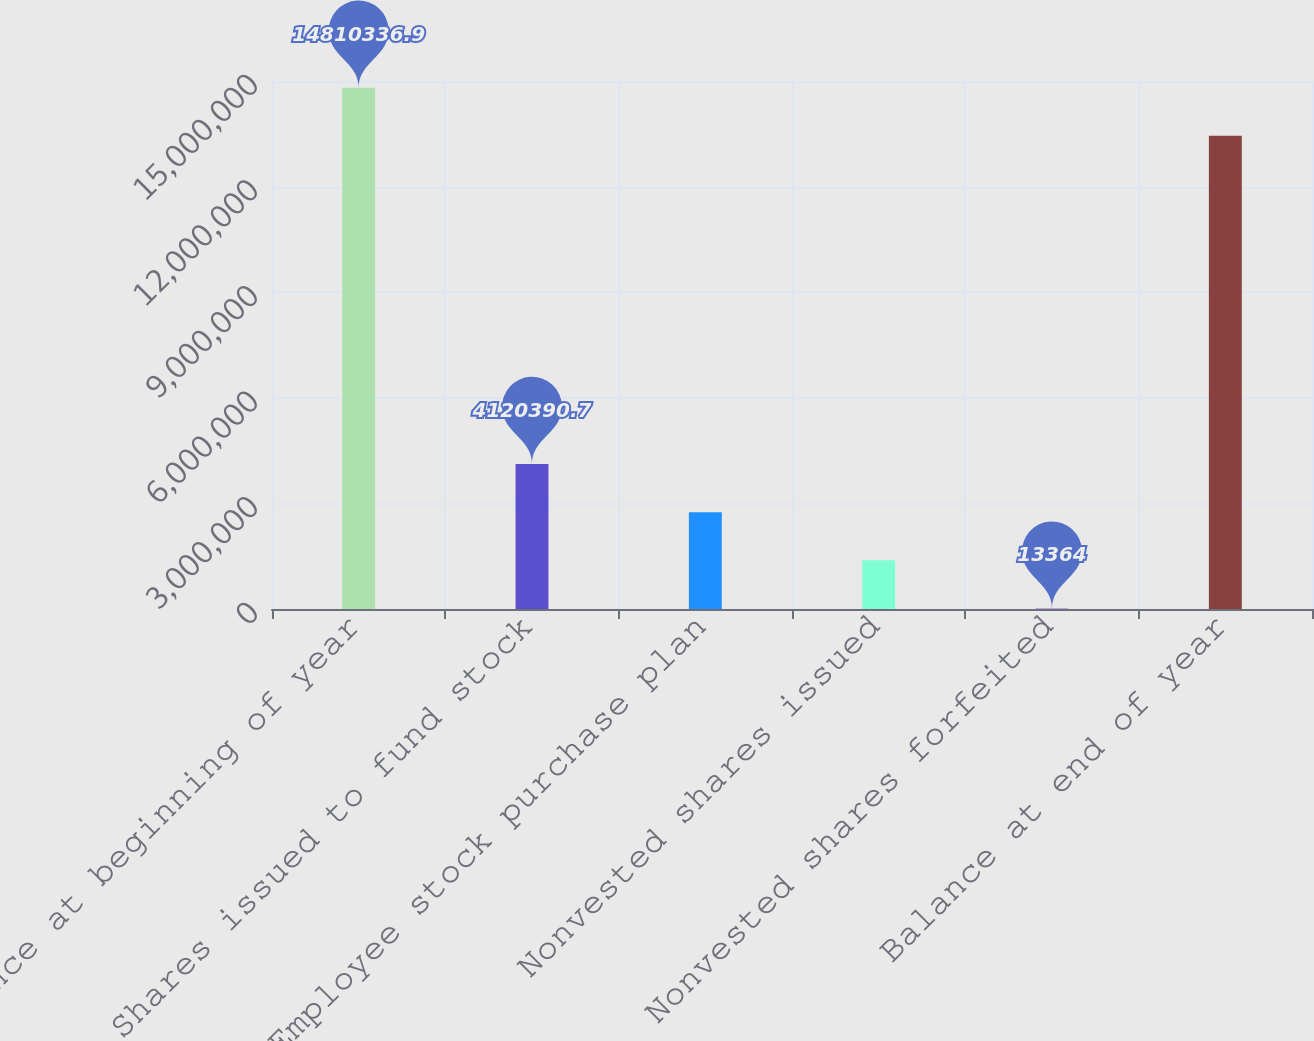Convert chart. <chart><loc_0><loc_0><loc_500><loc_500><bar_chart><fcel>Balance at beginning of year<fcel>Shares issued to fund stock<fcel>Employee stock purchase plan<fcel>Nonvested shares issued<fcel>Nonvested shares forfeited<fcel>Balance at end of year<nl><fcel>1.48103e+07<fcel>4.12039e+06<fcel>2.75138e+06<fcel>1.38237e+06<fcel>13364<fcel>1.34413e+07<nl></chart> 